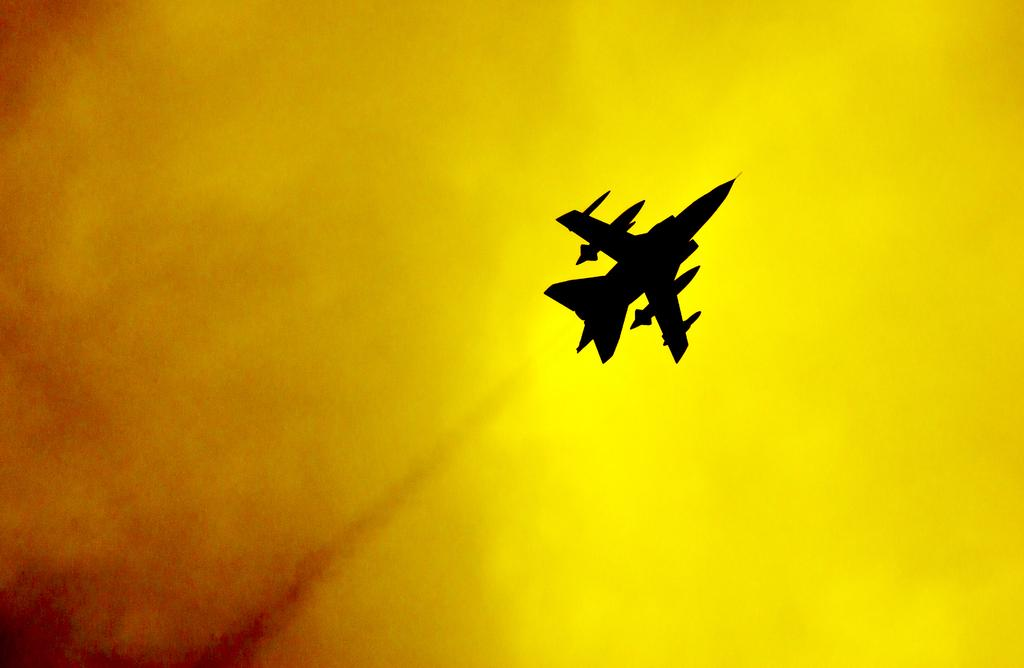What is the main subject in the image? There is a jet in the sky in the image. Can you describe the location of the jet in the image? The jet is in the sky in the image. What type of berry is being used as a fuel source for the jet in the image? There is no mention of berries or any other fuel source in the image; the jet is simply flying in the sky. How many spiders are crawling on the wings of the jet in the image? There are no spiders present on the jet in the image. 